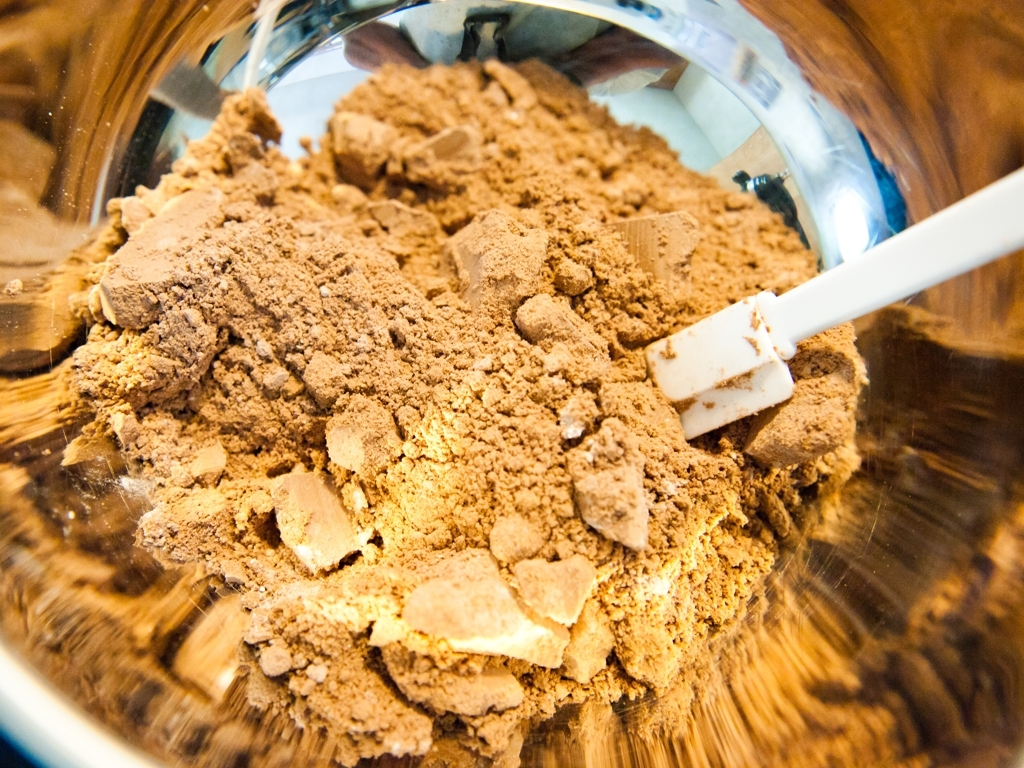What kind of atmosphere or feeling does this image evoke? This image has an intimate and immediate feel, placing the viewer right into the action, possibly during a moment of cooking or baking. The close-up on the powder creates a sense of focus and attention to detail, which is often associated with careful culinary preparation or the art of gastronomy. 